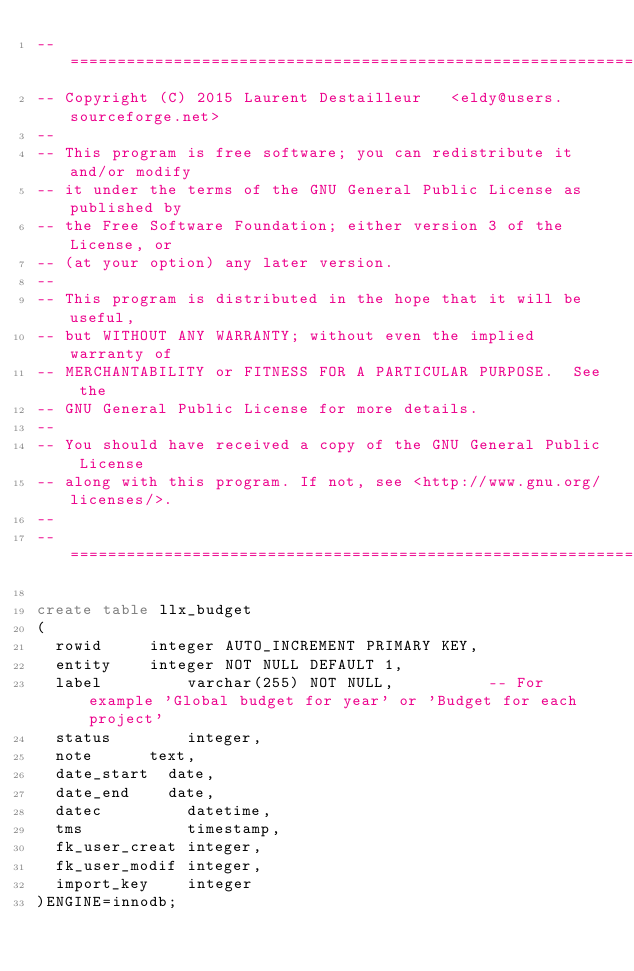<code> <loc_0><loc_0><loc_500><loc_500><_SQL_>-- ============================================================================
-- Copyright (C) 2015	Laurent Destailleur		<eldy@users.sourceforge.net>
--
-- This program is free software; you can redistribute it and/or modify
-- it under the terms of the GNU General Public License as published by
-- the Free Software Foundation; either version 3 of the License, or
-- (at your option) any later version.
--
-- This program is distributed in the hope that it will be useful,
-- but WITHOUT ANY WARRANTY; without even the implied warranty of
-- MERCHANTABILITY or FITNESS FOR A PARTICULAR PURPOSE.  See the
-- GNU General Public License for more details.
--
-- You should have received a copy of the GNU General Public License
-- along with this program. If not, see <http://www.gnu.org/licenses/>.
--
-- ===========================================================================

create table llx_budget
(
  rowid			integer AUTO_INCREMENT PRIMARY KEY,
  entity		integer NOT NULL DEFAULT 1,
  label         varchar(255) NOT NULL,					-- For example 'Global budget for year' or 'Budget for each project'
  status        integer,
  note			text,	
  date_start	date,
  date_end		date,
  datec         datetime,
  tms           timestamp,
  fk_user_creat integer,
  fk_user_modif integer,
  import_key    integer  
)ENGINE=innodb;
</code> 